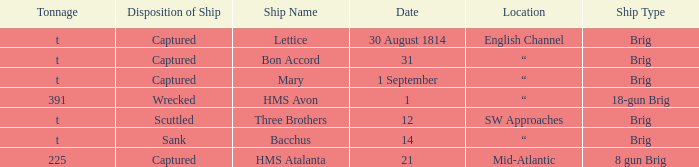With a tonnage of 225 what is the ship type? 8 gun Brig. 